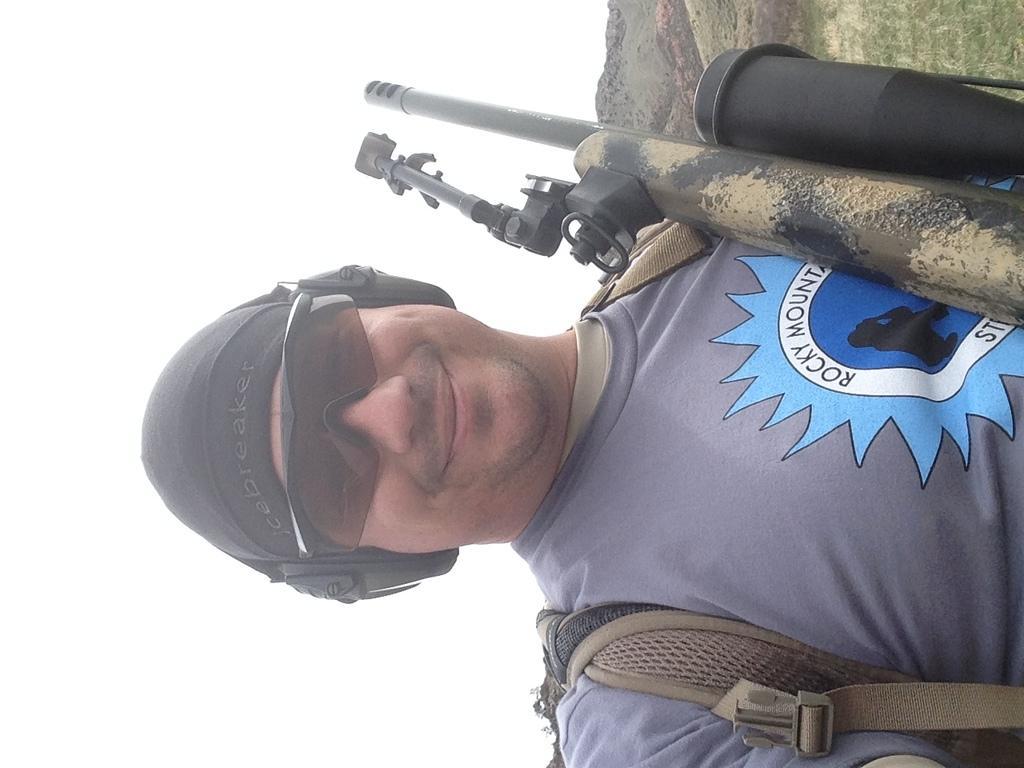Can you describe this image briefly? In this image, we can see a person wearing clothes, bag, sunglasses, headset and cap. There is a gun in the top right of the image. There is a sky on the left side of the image. 